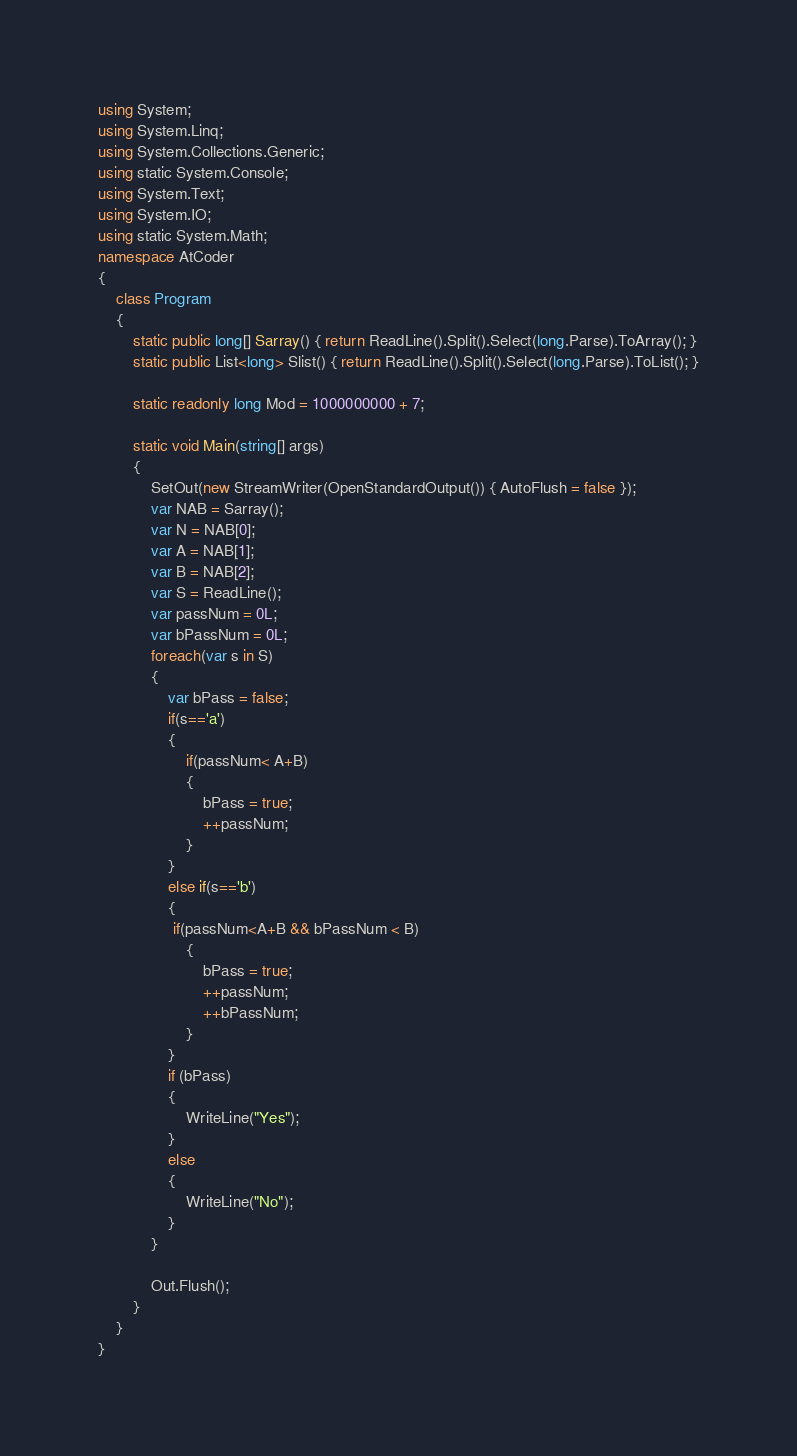Convert code to text. <code><loc_0><loc_0><loc_500><loc_500><_C#_>using System;
using System.Linq;
using System.Collections.Generic;
using static System.Console;
using System.Text;
using System.IO;
using static System.Math;
namespace AtCoder
{
    class Program
    {
        static public long[] Sarray() { return ReadLine().Split().Select(long.Parse).ToArray(); }
        static public List<long> Slist() { return ReadLine().Split().Select(long.Parse).ToList(); }

        static readonly long Mod = 1000000000 + 7;

        static void Main(string[] args)
        {
            SetOut(new StreamWriter(OpenStandardOutput()) { AutoFlush = false });
            var NAB = Sarray();
            var N = NAB[0];
            var A = NAB[1];
            var B = NAB[2];
            var S = ReadLine();
            var passNum = 0L;
            var bPassNum = 0L;
            foreach(var s in S)
            {
                var bPass = false;
                if(s=='a')
                {
                    if(passNum< A+B)
                    {
                        bPass = true;
                        ++passNum;
                    }
                }
                else if(s=='b')
                {
                 if(passNum<A+B && bPassNum < B)
                    {
                        bPass = true;
                        ++passNum;
                        ++bPassNum;
                    }
                }
                if (bPass)
                {
                    WriteLine("Yes");
                }
                else
                {
                    WriteLine("No");
                }
            }

            Out.Flush();
        }
    }
}</code> 